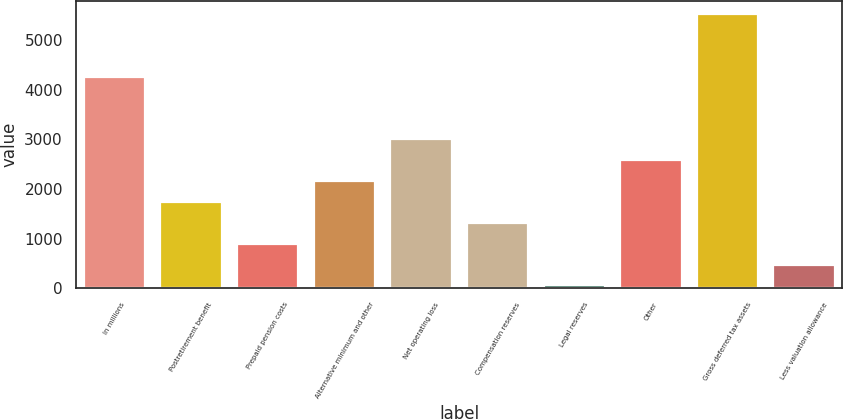Convert chart. <chart><loc_0><loc_0><loc_500><loc_500><bar_chart><fcel>In millions<fcel>Postretirement benefit<fcel>Prepaid pension costs<fcel>Alternative minimum and other<fcel>Net operating loss<fcel>Compensation reserves<fcel>Legal reserves<fcel>Other<fcel>Gross deferred tax assets<fcel>Less valuation allowance<nl><fcel>4252<fcel>1736.2<fcel>897.6<fcel>2155.5<fcel>2994.1<fcel>1316.9<fcel>59<fcel>2574.8<fcel>5509.9<fcel>478.3<nl></chart> 